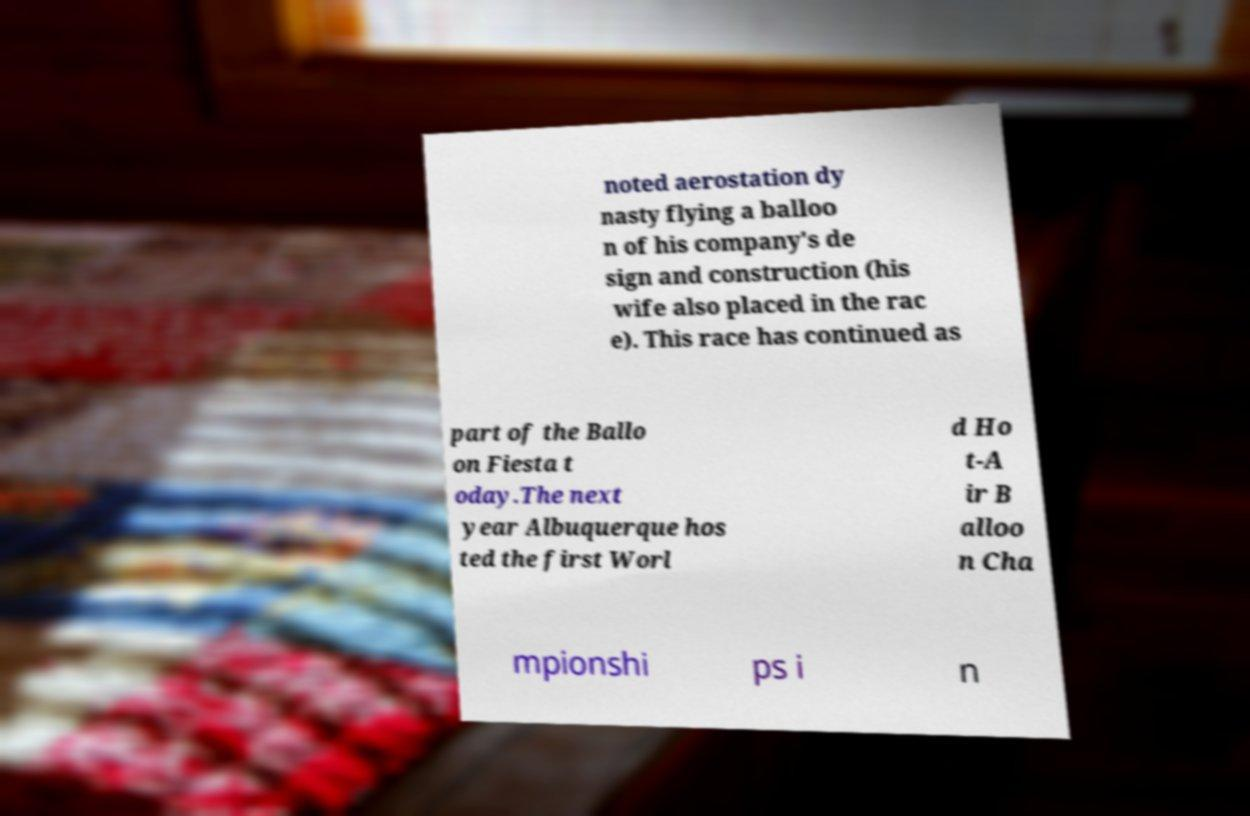Please read and relay the text visible in this image. What does it say? noted aerostation dy nasty flying a balloo n of his company's de sign and construction (his wife also placed in the rac e). This race has continued as part of the Ballo on Fiesta t oday.The next year Albuquerque hos ted the first Worl d Ho t-A ir B alloo n Cha mpionshi ps i n 